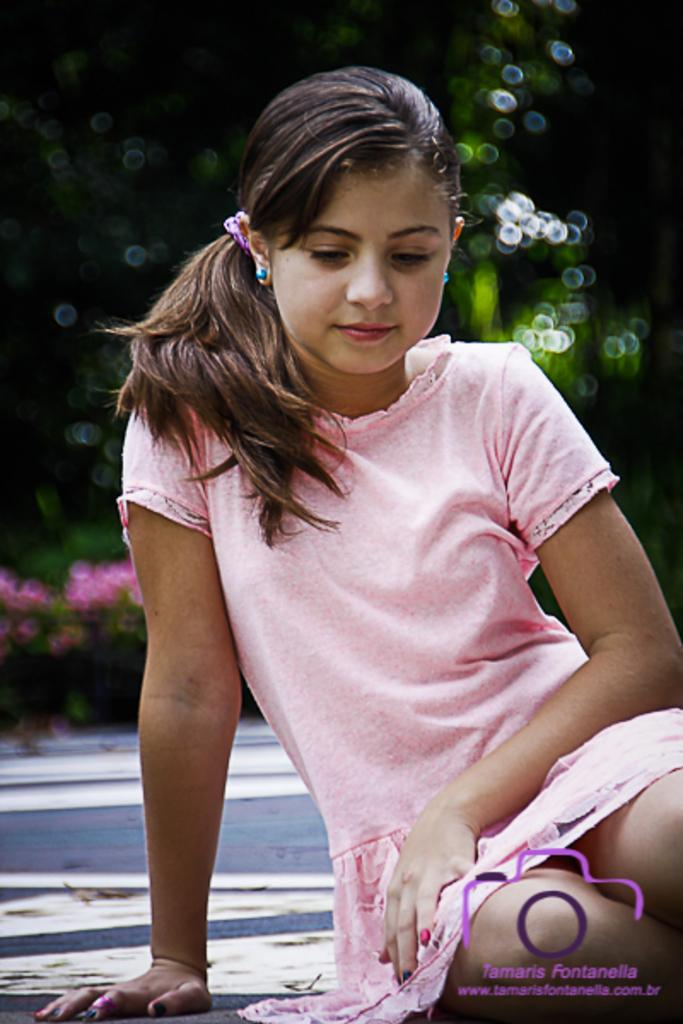Who is the main subject in the image? There is a girl in the image. What can be observed about the background of the image? The background of the image is blurred. Is there any additional information or markings present in the image? Yes, there is a watermark in the bottom right corner of the image. What type of food is the girl holding in the image? There is no food visible in the image; the girl is not holding any food. Can you tell me how many buttons are on the girl's shirt in the image? There is no shirt visible in the image, and therefore no buttons can be counted. 